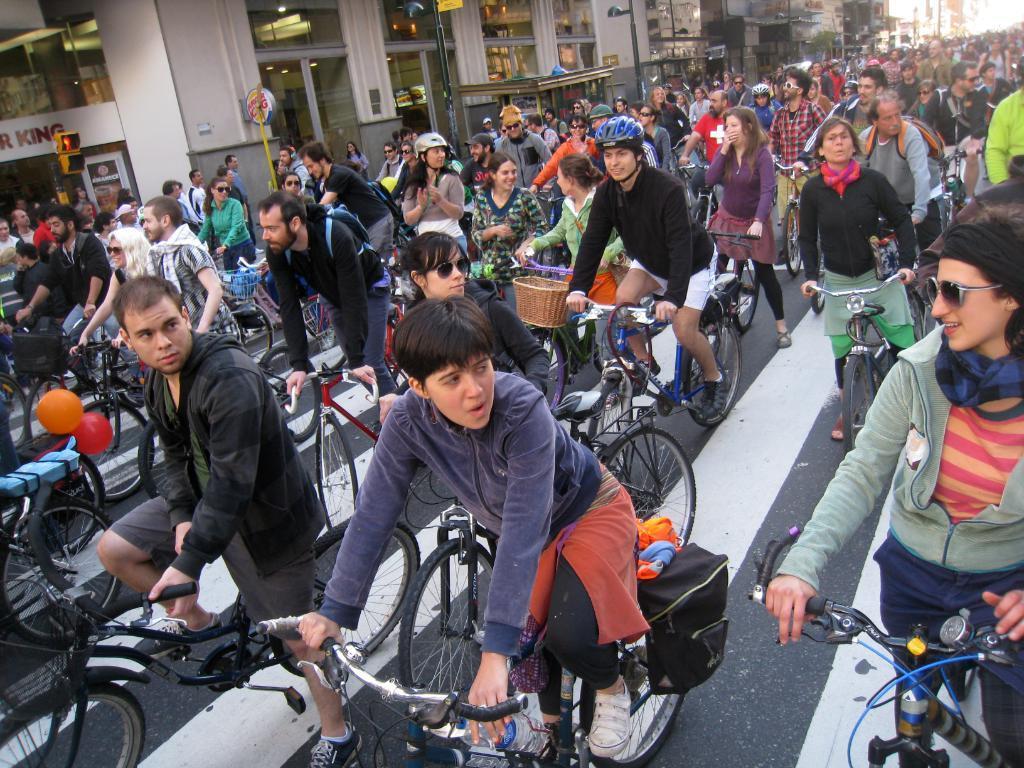Could you give a brief overview of what you see in this image? There are many people riding a bicycle on the road. Some of them were wearing helmets. Some of them were wearing spectacles. There are men and women in this picture. In the background there are some buildings. 